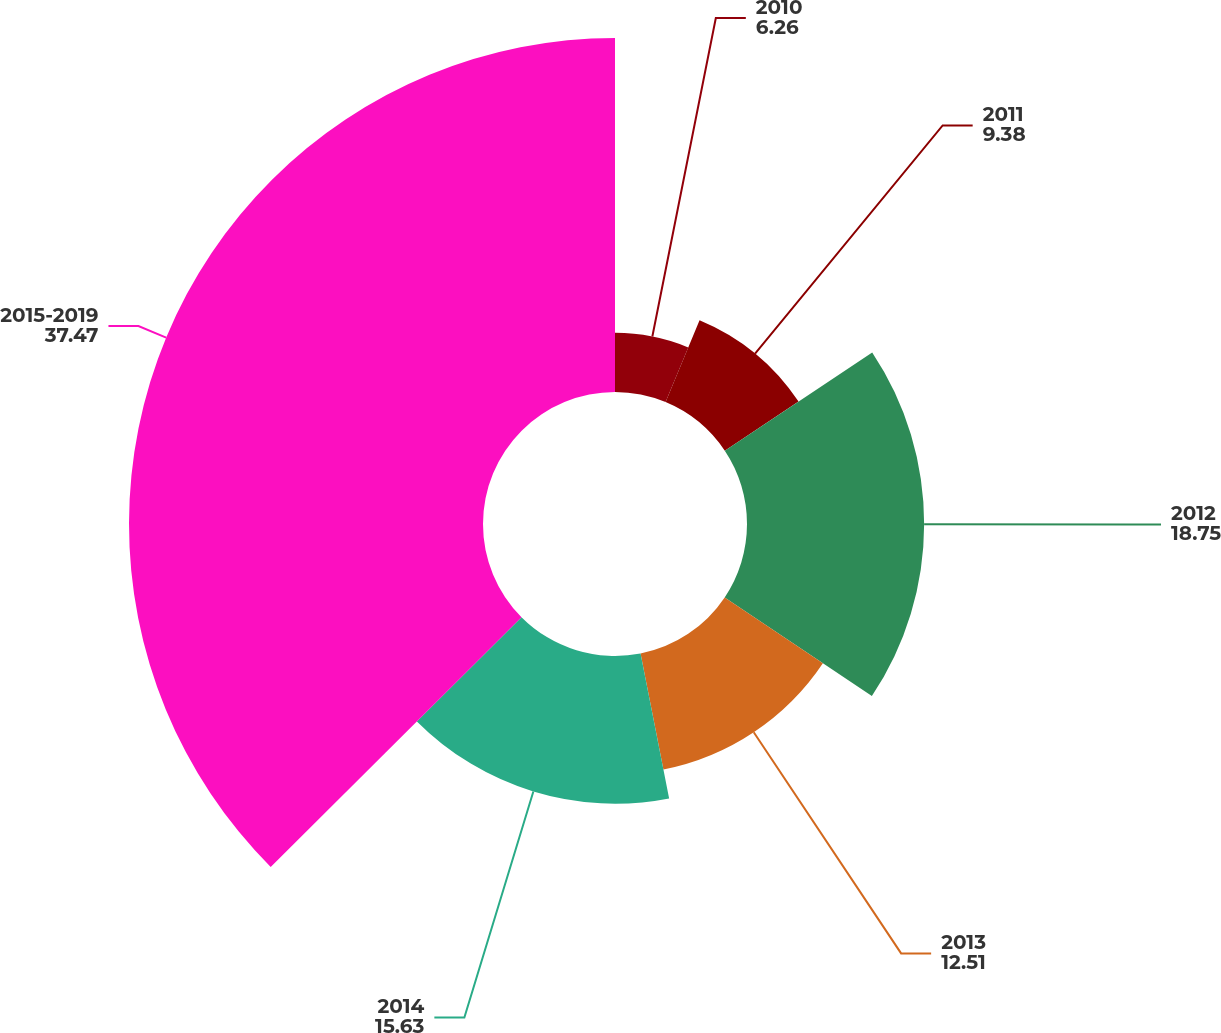Convert chart. <chart><loc_0><loc_0><loc_500><loc_500><pie_chart><fcel>2010<fcel>2011<fcel>2012<fcel>2013<fcel>2014<fcel>2015-2019<nl><fcel>6.26%<fcel>9.38%<fcel>18.75%<fcel>12.51%<fcel>15.63%<fcel>37.47%<nl></chart> 